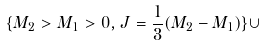<formula> <loc_0><loc_0><loc_500><loc_500>\{ M _ { 2 } > M _ { 1 } > 0 , J = \frac { 1 } { 3 } ( M _ { 2 } - M _ { 1 } ) \} \cup</formula> 